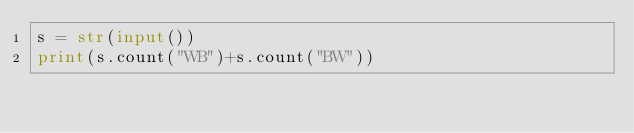Convert code to text. <code><loc_0><loc_0><loc_500><loc_500><_Python_>s = str(input())
print(s.count("WB")+s.count("BW"))</code> 